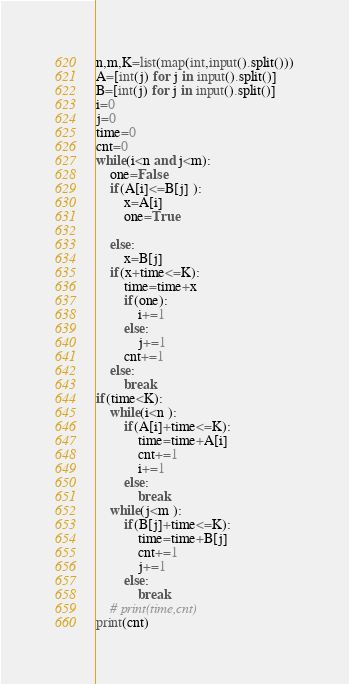<code> <loc_0><loc_0><loc_500><loc_500><_Python_>
n,m,K=list(map(int,input().split()))
A=[int(j) for j in input().split()]
B=[int(j) for j in input().split()]
i=0
j=0
time=0
cnt=0
while(i<n and j<m):
    one=False
    if(A[i]<=B[j] ):
        x=A[i]
        one=True

    else:
        x=B[j]
    if(x+time<=K):
        time=time+x
        if(one):
            i+=1
        else:
            j+=1
        cnt+=1
    else:
        break
if(time<K):
    while(i<n ):
        if(A[i]+time<=K):
            time=time+A[i]
            cnt+=1
            i+=1
        else:
            break
    while(j<m ):
        if(B[j]+time<=K):
            time=time+B[j]
            cnt+=1
            j+=1
        else:
            break
    # print(time,cnt)
print(cnt)</code> 